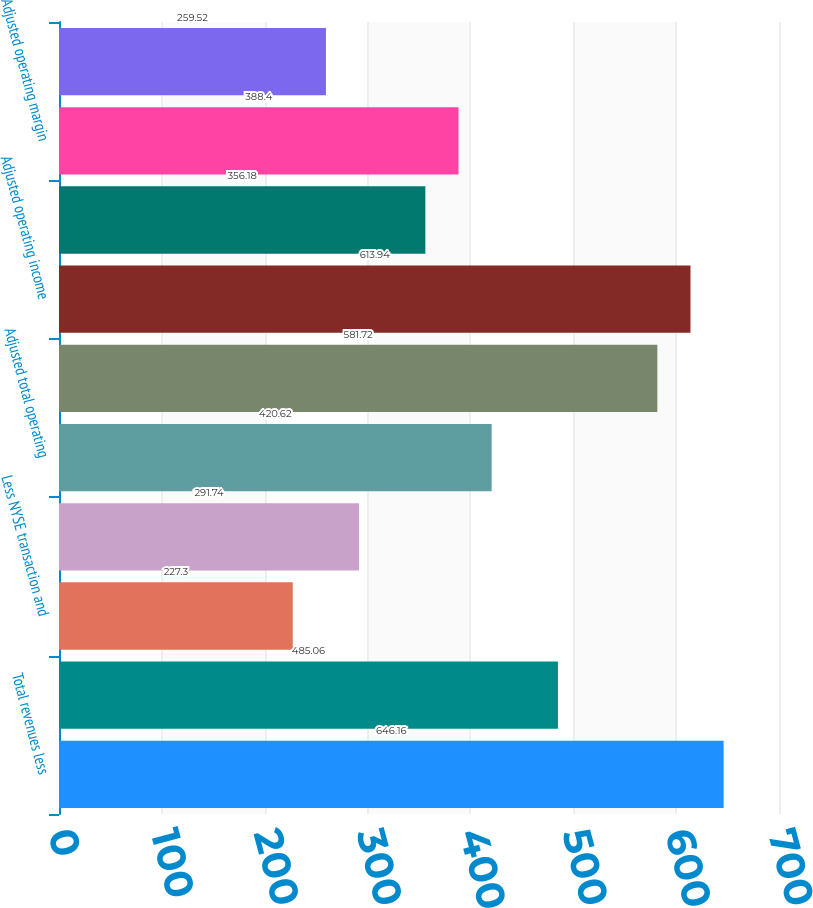Convert chart. <chart><loc_0><loc_0><loc_500><loc_500><bar_chart><fcel>Total revenues less<fcel>Total operating expenses<fcel>Less NYSE transaction and<fcel>Less Amortization of<fcel>Adjusted total operating<fcel>Operating income<fcel>Adjusted operating income<fcel>Operating margin<fcel>Adjusted operating margin<fcel>Add NYSE transaction and<nl><fcel>646.16<fcel>485.06<fcel>227.3<fcel>291.74<fcel>420.62<fcel>581.72<fcel>613.94<fcel>356.18<fcel>388.4<fcel>259.52<nl></chart> 